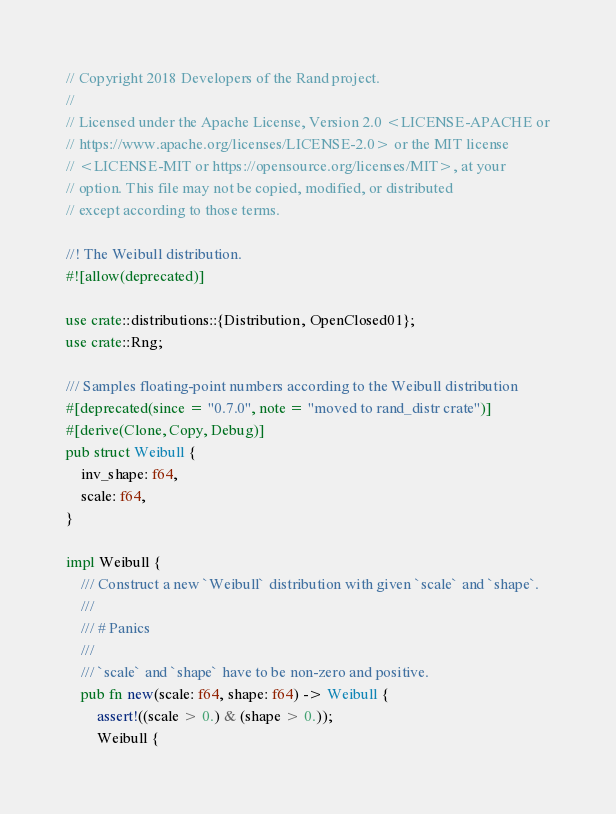<code> <loc_0><loc_0><loc_500><loc_500><_Rust_>// Copyright 2018 Developers of the Rand project.
//
// Licensed under the Apache License, Version 2.0 <LICENSE-APACHE or
// https://www.apache.org/licenses/LICENSE-2.0> or the MIT license
// <LICENSE-MIT or https://opensource.org/licenses/MIT>, at your
// option. This file may not be copied, modified, or distributed
// except according to those terms.

//! The Weibull distribution.
#![allow(deprecated)]

use crate::distributions::{Distribution, OpenClosed01};
use crate::Rng;

/// Samples floating-point numbers according to the Weibull distribution
#[deprecated(since = "0.7.0", note = "moved to rand_distr crate")]
#[derive(Clone, Copy, Debug)]
pub struct Weibull {
    inv_shape: f64,
    scale: f64,
}

impl Weibull {
    /// Construct a new `Weibull` distribution with given `scale` and `shape`.
    ///
    /// # Panics
    ///
    /// `scale` and `shape` have to be non-zero and positive.
    pub fn new(scale: f64, shape: f64) -> Weibull {
        assert!((scale > 0.) & (shape > 0.));
        Weibull {</code> 